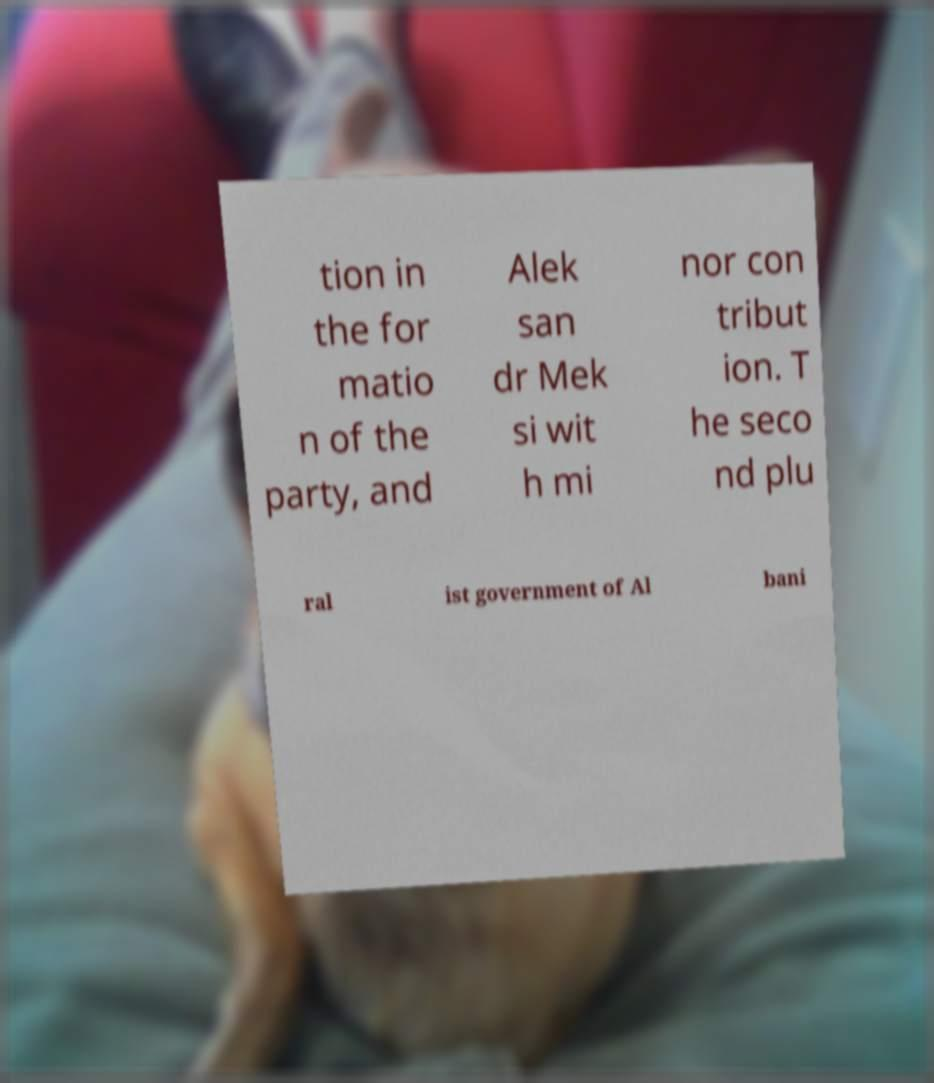Please read and relay the text visible in this image. What does it say? tion in the for matio n of the party, and Alek san dr Mek si wit h mi nor con tribut ion. T he seco nd plu ral ist government of Al bani 